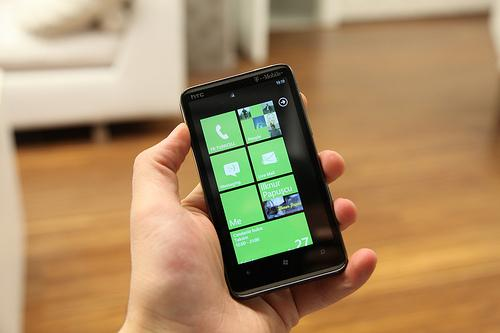Examine the picture's overall sentiment and atmosphere. The image exudes a casual, relaxed atmosphere with the person interacting with their smartphone in a comfortable living room setting. Based on the visual representations, identify a complex reasoning task that could be performed. Determine the type of phone plan the person might be using based on the displayed icons and features, like the T-Mobile logo and the signal strength indicator. Write a caption for the scene including the person and items in the background. Person holding up a smartphone with a bright screen, while a cozy living room with a white couch and wooden flooring can be seen in the background. Identify and describe the most prominent color within the image. A light brown hardwood floor that covers the majority of the image's background. Elaborate on the type of application or function displayed on the phone's screen. The phone screen displays green and white icons including a male icon, a texting logo, a phone icon, and an envelope, which suggests it's the main menu. Provide a brief description of the primary object in the image. A person is holding a smart phone in their hand, displaying a screen with various icons and features. Considering the visual details of the scene, describe the quality of the image. The image is of high quality with clear visibility of the person, smartphone, and various items in the background such as the couch and floor. Count the number of major objects in the image and list them. 6 major objects: person with phone, white couch, wooden floor, opened door, white pillow, cellphone screen. Is the device in the person's hand turned on, and what kind of device is it? Yes, the device is on. It is a Windows cell phone with an HTC logo. Analyze the interaction between the person and the electronic device. The person is actively engaging with the electronic device as they are holding it up with one hand to see the screen and its contents. Could you find the large green tree in the image? No, it's not mentioned in the image. Can you see the black couch on the wooden floor? There is no black couch in the image, but there is a white couch on the wooden floor. Do you notice a closed door in the background? There is a mention of an open door in the image, not a closed one, making the instruction misleading. Is there a dog lying on the wooden floor? There is no mention of a dog in the image, only a white couch and a wooden floor are present. Could you find the cell phone being held by a person with a blue hand? There is a person holding a cellphone in the image, but their hand is described as white, not blue. 